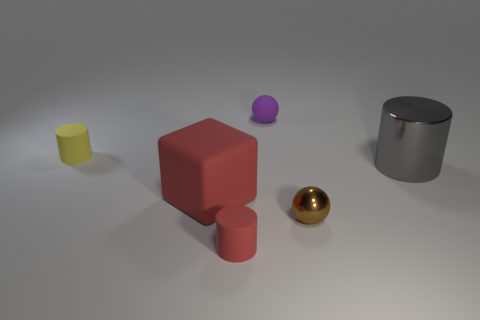How many things are either small brown shiny things or red objects?
Offer a terse response. 3. Is there another yellow object of the same size as the yellow matte thing?
Your answer should be very brief. No. There is a purple matte thing; what shape is it?
Offer a very short reply. Sphere. Is the number of cylinders that are to the left of the matte cube greater than the number of tiny matte spheres to the left of the brown ball?
Your answer should be compact. No. Does the sphere in front of the small yellow matte cylinder have the same color as the tiny cylinder in front of the tiny brown shiny ball?
Give a very brief answer. No. The matte object that is the same size as the gray cylinder is what shape?
Ensure brevity in your answer.  Cube. Are there any large gray metallic things of the same shape as the purple object?
Offer a very short reply. No. Are the big object that is right of the brown sphere and the cylinder to the left of the big red block made of the same material?
Provide a succinct answer. No. The matte thing that is the same color as the big matte cube is what shape?
Ensure brevity in your answer.  Cylinder. How many tiny spheres are made of the same material as the small yellow thing?
Your response must be concise. 1. 